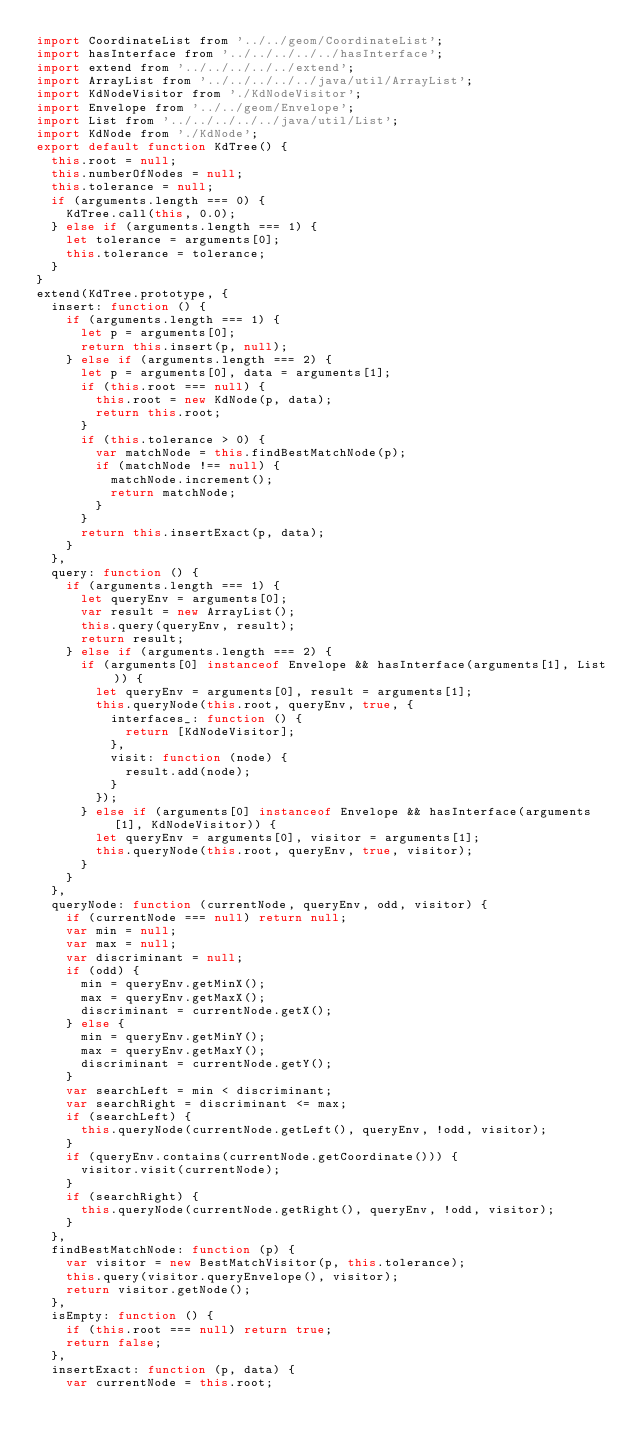Convert code to text. <code><loc_0><loc_0><loc_500><loc_500><_JavaScript_>import CoordinateList from '../../geom/CoordinateList';
import hasInterface from '../../../../../hasInterface';
import extend from '../../../../../extend';
import ArrayList from '../../../../../java/util/ArrayList';
import KdNodeVisitor from './KdNodeVisitor';
import Envelope from '../../geom/Envelope';
import List from '../../../../../java/util/List';
import KdNode from './KdNode';
export default function KdTree() {
	this.root = null;
	this.numberOfNodes = null;
	this.tolerance = null;
	if (arguments.length === 0) {
		KdTree.call(this, 0.0);
	} else if (arguments.length === 1) {
		let tolerance = arguments[0];
		this.tolerance = tolerance;
	}
}
extend(KdTree.prototype, {
	insert: function () {
		if (arguments.length === 1) {
			let p = arguments[0];
			return this.insert(p, null);
		} else if (arguments.length === 2) {
			let p = arguments[0], data = arguments[1];
			if (this.root === null) {
				this.root = new KdNode(p, data);
				return this.root;
			}
			if (this.tolerance > 0) {
				var matchNode = this.findBestMatchNode(p);
				if (matchNode !== null) {
					matchNode.increment();
					return matchNode;
				}
			}
			return this.insertExact(p, data);
		}
	},
	query: function () {
		if (arguments.length === 1) {
			let queryEnv = arguments[0];
			var result = new ArrayList();
			this.query(queryEnv, result);
			return result;
		} else if (arguments.length === 2) {
			if (arguments[0] instanceof Envelope && hasInterface(arguments[1], List)) {
				let queryEnv = arguments[0], result = arguments[1];
				this.queryNode(this.root, queryEnv, true, {
					interfaces_: function () {
						return [KdNodeVisitor];
					},
					visit: function (node) {
						result.add(node);
					}
				});
			} else if (arguments[0] instanceof Envelope && hasInterface(arguments[1], KdNodeVisitor)) {
				let queryEnv = arguments[0], visitor = arguments[1];
				this.queryNode(this.root, queryEnv, true, visitor);
			}
		}
	},
	queryNode: function (currentNode, queryEnv, odd, visitor) {
		if (currentNode === null) return null;
		var min = null;
		var max = null;
		var discriminant = null;
		if (odd) {
			min = queryEnv.getMinX();
			max = queryEnv.getMaxX();
			discriminant = currentNode.getX();
		} else {
			min = queryEnv.getMinY();
			max = queryEnv.getMaxY();
			discriminant = currentNode.getY();
		}
		var searchLeft = min < discriminant;
		var searchRight = discriminant <= max;
		if (searchLeft) {
			this.queryNode(currentNode.getLeft(), queryEnv, !odd, visitor);
		}
		if (queryEnv.contains(currentNode.getCoordinate())) {
			visitor.visit(currentNode);
		}
		if (searchRight) {
			this.queryNode(currentNode.getRight(), queryEnv, !odd, visitor);
		}
	},
	findBestMatchNode: function (p) {
		var visitor = new BestMatchVisitor(p, this.tolerance);
		this.query(visitor.queryEnvelope(), visitor);
		return visitor.getNode();
	},
	isEmpty: function () {
		if (this.root === null) return true;
		return false;
	},
	insertExact: function (p, data) {
		var currentNode = this.root;</code> 